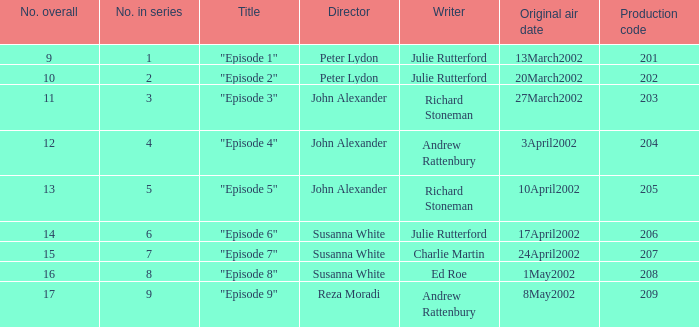Who holds the director position when the sequence features 1? Peter Lydon. 